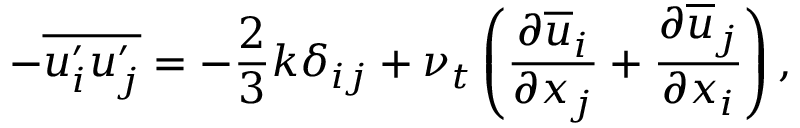Convert formula to latex. <formula><loc_0><loc_0><loc_500><loc_500>- \overline { { u _ { i } ^ { \prime } u _ { j } ^ { \prime } } } = - \frac { 2 } { 3 } k \delta _ { i j } + \nu _ { t } \left ( \frac { \partial \overline { u } _ { i } } { \partial x _ { j } } + \frac { \partial \overline { u } _ { j } } { \partial x _ { i } } \right ) ,</formula> 